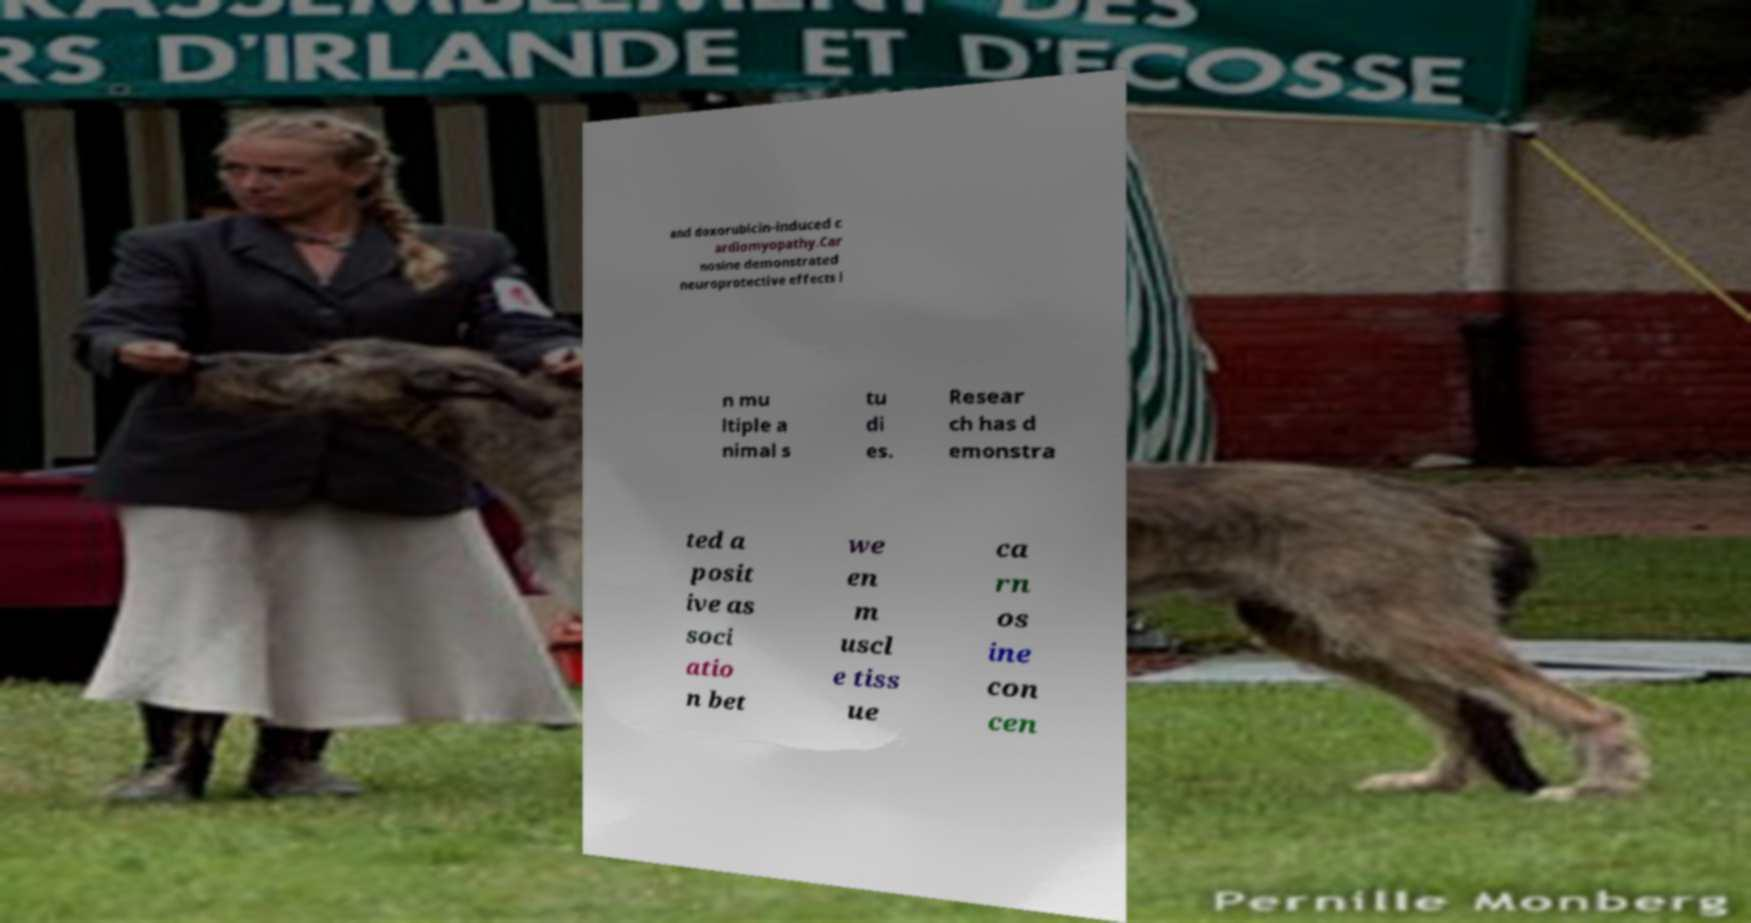I need the written content from this picture converted into text. Can you do that? and doxorubicin-induced c ardiomyopathy.Car nosine demonstrated neuroprotective effects i n mu ltiple a nimal s tu di es. Resear ch has d emonstra ted a posit ive as soci atio n bet we en m uscl e tiss ue ca rn os ine con cen 